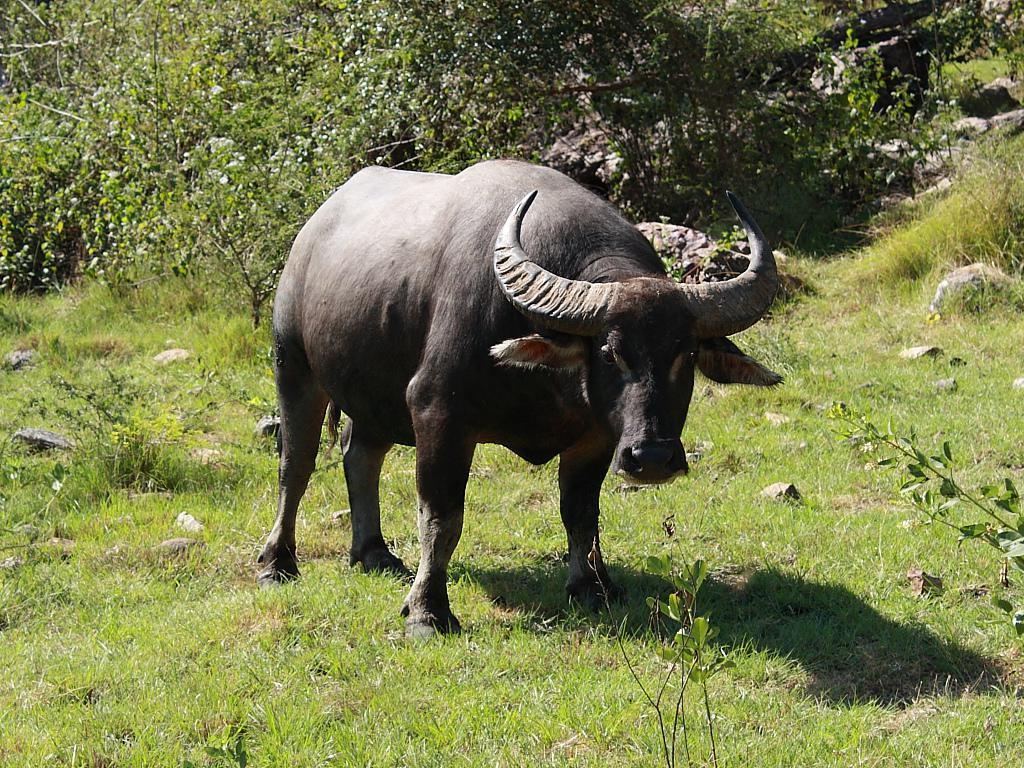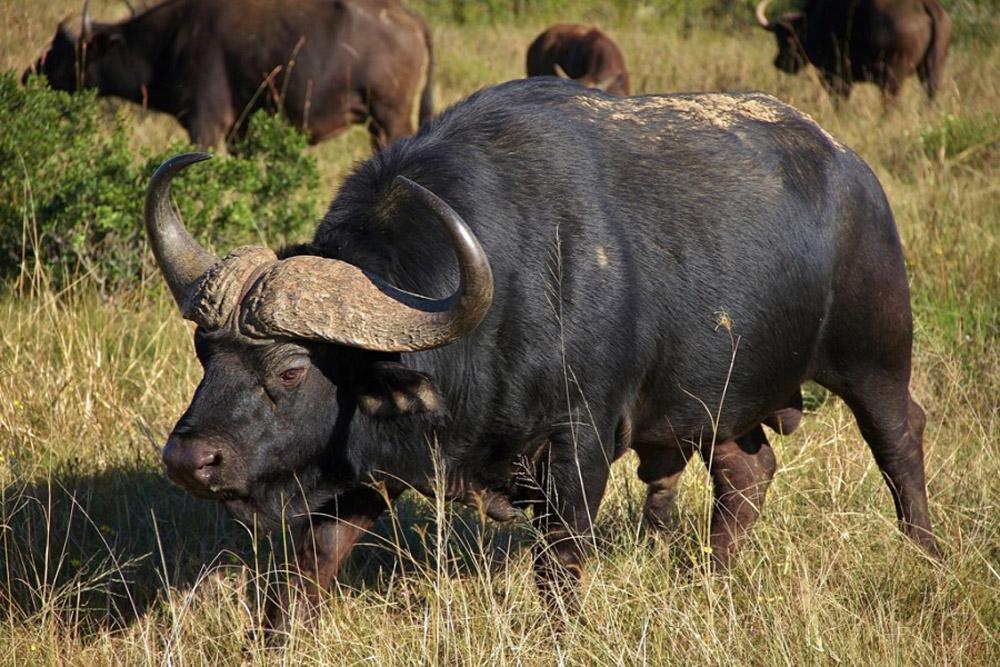The first image is the image on the left, the second image is the image on the right. Considering the images on both sides, is "The water buffalo in the right image is facing towards the right." valid? Answer yes or no. No. 